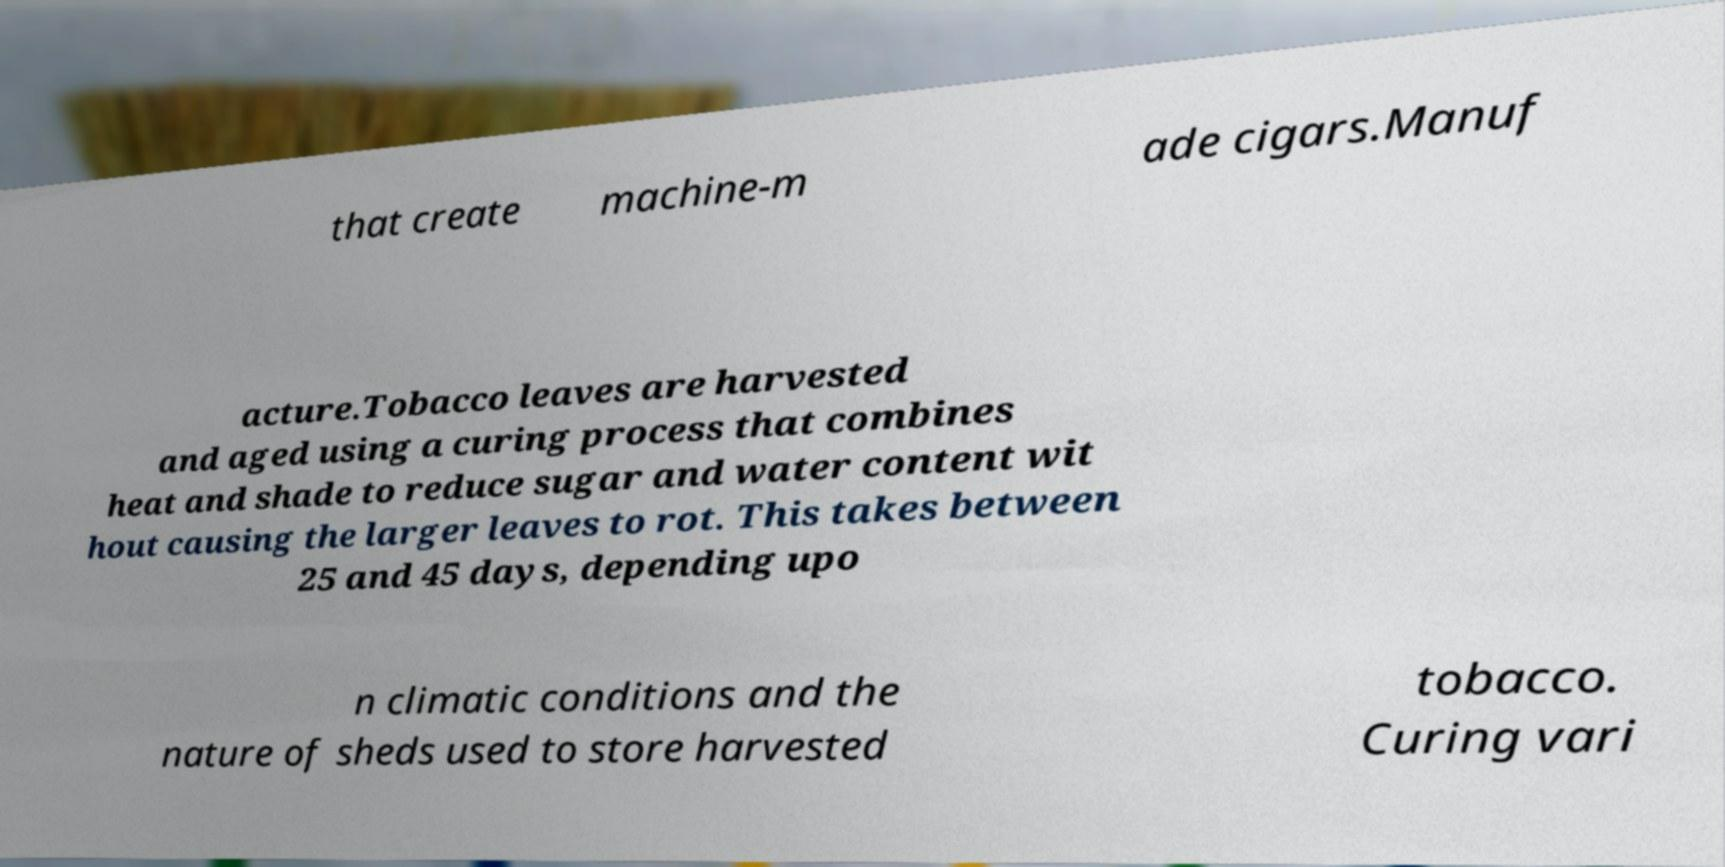There's text embedded in this image that I need extracted. Can you transcribe it verbatim? that create machine-m ade cigars.Manuf acture.Tobacco leaves are harvested and aged using a curing process that combines heat and shade to reduce sugar and water content wit hout causing the larger leaves to rot. This takes between 25 and 45 days, depending upo n climatic conditions and the nature of sheds used to store harvested tobacco. Curing vari 